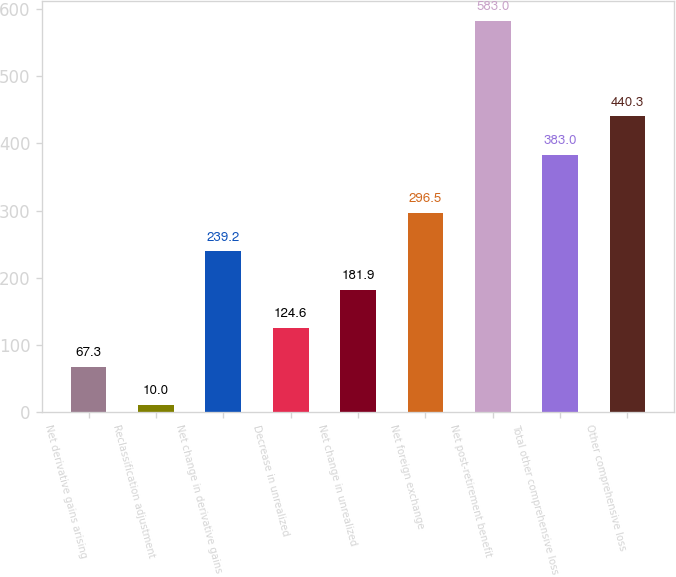<chart> <loc_0><loc_0><loc_500><loc_500><bar_chart><fcel>Net derivative gains arising<fcel>Reclassification adjustment<fcel>Net change in derivative gains<fcel>Decrease in unrealized<fcel>Net change in unrealized<fcel>Net foreign exchange<fcel>Net post-retirement benefit<fcel>Total other comprehensive loss<fcel>Other comprehensive loss<nl><fcel>67.3<fcel>10<fcel>239.2<fcel>124.6<fcel>181.9<fcel>296.5<fcel>583<fcel>383<fcel>440.3<nl></chart> 